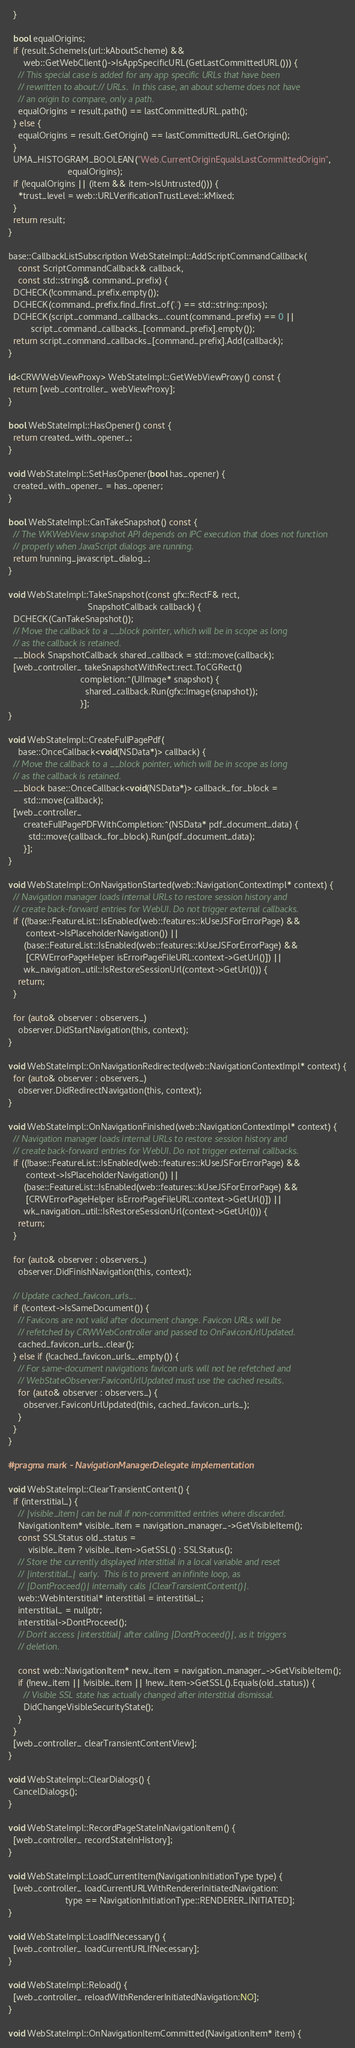<code> <loc_0><loc_0><loc_500><loc_500><_ObjectiveC_>  }

  bool equalOrigins;
  if (result.SchemeIs(url::kAboutScheme) &&
      web::GetWebClient()->IsAppSpecificURL(GetLastCommittedURL())) {
    // This special case is added for any app specific URLs that have been
    // rewritten to about:// URLs.  In this case, an about scheme does not have
    // an origin to compare, only a path.
    equalOrigins = result.path() == lastCommittedURL.path();
  } else {
    equalOrigins = result.GetOrigin() == lastCommittedURL.GetOrigin();
  }
  UMA_HISTOGRAM_BOOLEAN("Web.CurrentOriginEqualsLastCommittedOrigin",
                        equalOrigins);
  if (!equalOrigins || (item && item->IsUntrusted())) {
    *trust_level = web::URLVerificationTrustLevel::kMixed;
  }
  return result;
}

base::CallbackListSubscription WebStateImpl::AddScriptCommandCallback(
    const ScriptCommandCallback& callback,
    const std::string& command_prefix) {
  DCHECK(!command_prefix.empty());
  DCHECK(command_prefix.find_first_of('.') == std::string::npos);
  DCHECK(script_command_callbacks_.count(command_prefix) == 0 ||
         script_command_callbacks_[command_prefix].empty());
  return script_command_callbacks_[command_prefix].Add(callback);
}

id<CRWWebViewProxy> WebStateImpl::GetWebViewProxy() const {
  return [web_controller_ webViewProxy];
}

bool WebStateImpl::HasOpener() const {
  return created_with_opener_;
}

void WebStateImpl::SetHasOpener(bool has_opener) {
  created_with_opener_ = has_opener;
}

bool WebStateImpl::CanTakeSnapshot() const {
  // The WKWebView snapshot API depends on IPC execution that does not function
  // properly when JavaScript dialogs are running.
  return !running_javascript_dialog_;
}

void WebStateImpl::TakeSnapshot(const gfx::RectF& rect,
                                SnapshotCallback callback) {
  DCHECK(CanTakeSnapshot());
  // Move the callback to a __block pointer, which will be in scope as long
  // as the callback is retained.
  __block SnapshotCallback shared_callback = std::move(callback);
  [web_controller_ takeSnapshotWithRect:rect.ToCGRect()
                             completion:^(UIImage* snapshot) {
                               shared_callback.Run(gfx::Image(snapshot));
                             }];
}

void WebStateImpl::CreateFullPagePdf(
    base::OnceCallback<void(NSData*)> callback) {
  // Move the callback to a __block pointer, which will be in scope as long
  // as the callback is retained.
  __block base::OnceCallback<void(NSData*)> callback_for_block =
      std::move(callback);
  [web_controller_
      createFullPagePDFWithCompletion:^(NSData* pdf_document_data) {
        std::move(callback_for_block).Run(pdf_document_data);
      }];
}

void WebStateImpl::OnNavigationStarted(web::NavigationContextImpl* context) {
  // Navigation manager loads internal URLs to restore session history and
  // create back-forward entries for WebUI. Do not trigger external callbacks.
  if ((!base::FeatureList::IsEnabled(web::features::kUseJSForErrorPage) &&
       context->IsPlaceholderNavigation()) ||
      (base::FeatureList::IsEnabled(web::features::kUseJSForErrorPage) &&
       [CRWErrorPageHelper isErrorPageFileURL:context->GetUrl()]) ||
      wk_navigation_util::IsRestoreSessionUrl(context->GetUrl())) {
    return;
  }

  for (auto& observer : observers_)
    observer.DidStartNavigation(this, context);
}

void WebStateImpl::OnNavigationRedirected(web::NavigationContextImpl* context) {
  for (auto& observer : observers_)
    observer.DidRedirectNavigation(this, context);
}

void WebStateImpl::OnNavigationFinished(web::NavigationContextImpl* context) {
  // Navigation manager loads internal URLs to restore session history and
  // create back-forward entries for WebUI. Do not trigger external callbacks.
  if ((!base::FeatureList::IsEnabled(web::features::kUseJSForErrorPage) &&
       context->IsPlaceholderNavigation()) ||
      (base::FeatureList::IsEnabled(web::features::kUseJSForErrorPage) &&
       [CRWErrorPageHelper isErrorPageFileURL:context->GetUrl()]) ||
      wk_navigation_util::IsRestoreSessionUrl(context->GetUrl())) {
    return;
  }

  for (auto& observer : observers_)
    observer.DidFinishNavigation(this, context);

  // Update cached_favicon_urls_.
  if (!context->IsSameDocument()) {
    // Favicons are not valid after document change. Favicon URLs will be
    // refetched by CRWWebController and passed to OnFaviconUrlUpdated.
    cached_favicon_urls_.clear();
  } else if (!cached_favicon_urls_.empty()) {
    // For same-document navigations favicon urls will not be refetched and
    // WebStateObserver:FaviconUrlUpdated must use the cached results.
    for (auto& observer : observers_) {
      observer.FaviconUrlUpdated(this, cached_favicon_urls_);
    }
  }
}

#pragma mark - NavigationManagerDelegate implementation

void WebStateImpl::ClearTransientContent() {
  if (interstitial_) {
    // |visible_item| can be null if non-committed entries where discarded.
    NavigationItem* visible_item = navigation_manager_->GetVisibleItem();
    const SSLStatus old_status =
        visible_item ? visible_item->GetSSL() : SSLStatus();
    // Store the currently displayed interstitial in a local variable and reset
    // |interstitial_| early.  This is to prevent an infinite loop, as
    // |DontProceed()| internally calls |ClearTransientContent()|.
    web::WebInterstitial* interstitial = interstitial_;
    interstitial_ = nullptr;
    interstitial->DontProceed();
    // Don't access |interstitial| after calling |DontProceed()|, as it triggers
    // deletion.

    const web::NavigationItem* new_item = navigation_manager_->GetVisibleItem();
    if (!new_item || !visible_item || !new_item->GetSSL().Equals(old_status)) {
      // Visible SSL state has actually changed after interstitial dismissal.
      DidChangeVisibleSecurityState();
    }
  }
  [web_controller_ clearTransientContentView];
}

void WebStateImpl::ClearDialogs() {
  CancelDialogs();
}

void WebStateImpl::RecordPageStateInNavigationItem() {
  [web_controller_ recordStateInHistory];
}

void WebStateImpl::LoadCurrentItem(NavigationInitiationType type) {
  [web_controller_ loadCurrentURLWithRendererInitiatedNavigation:
                       type == NavigationInitiationType::RENDERER_INITIATED];
}

void WebStateImpl::LoadIfNecessary() {
  [web_controller_ loadCurrentURLIfNecessary];
}

void WebStateImpl::Reload() {
  [web_controller_ reloadWithRendererInitiatedNavigation:NO];
}

void WebStateImpl::OnNavigationItemCommitted(NavigationItem* item) {</code> 